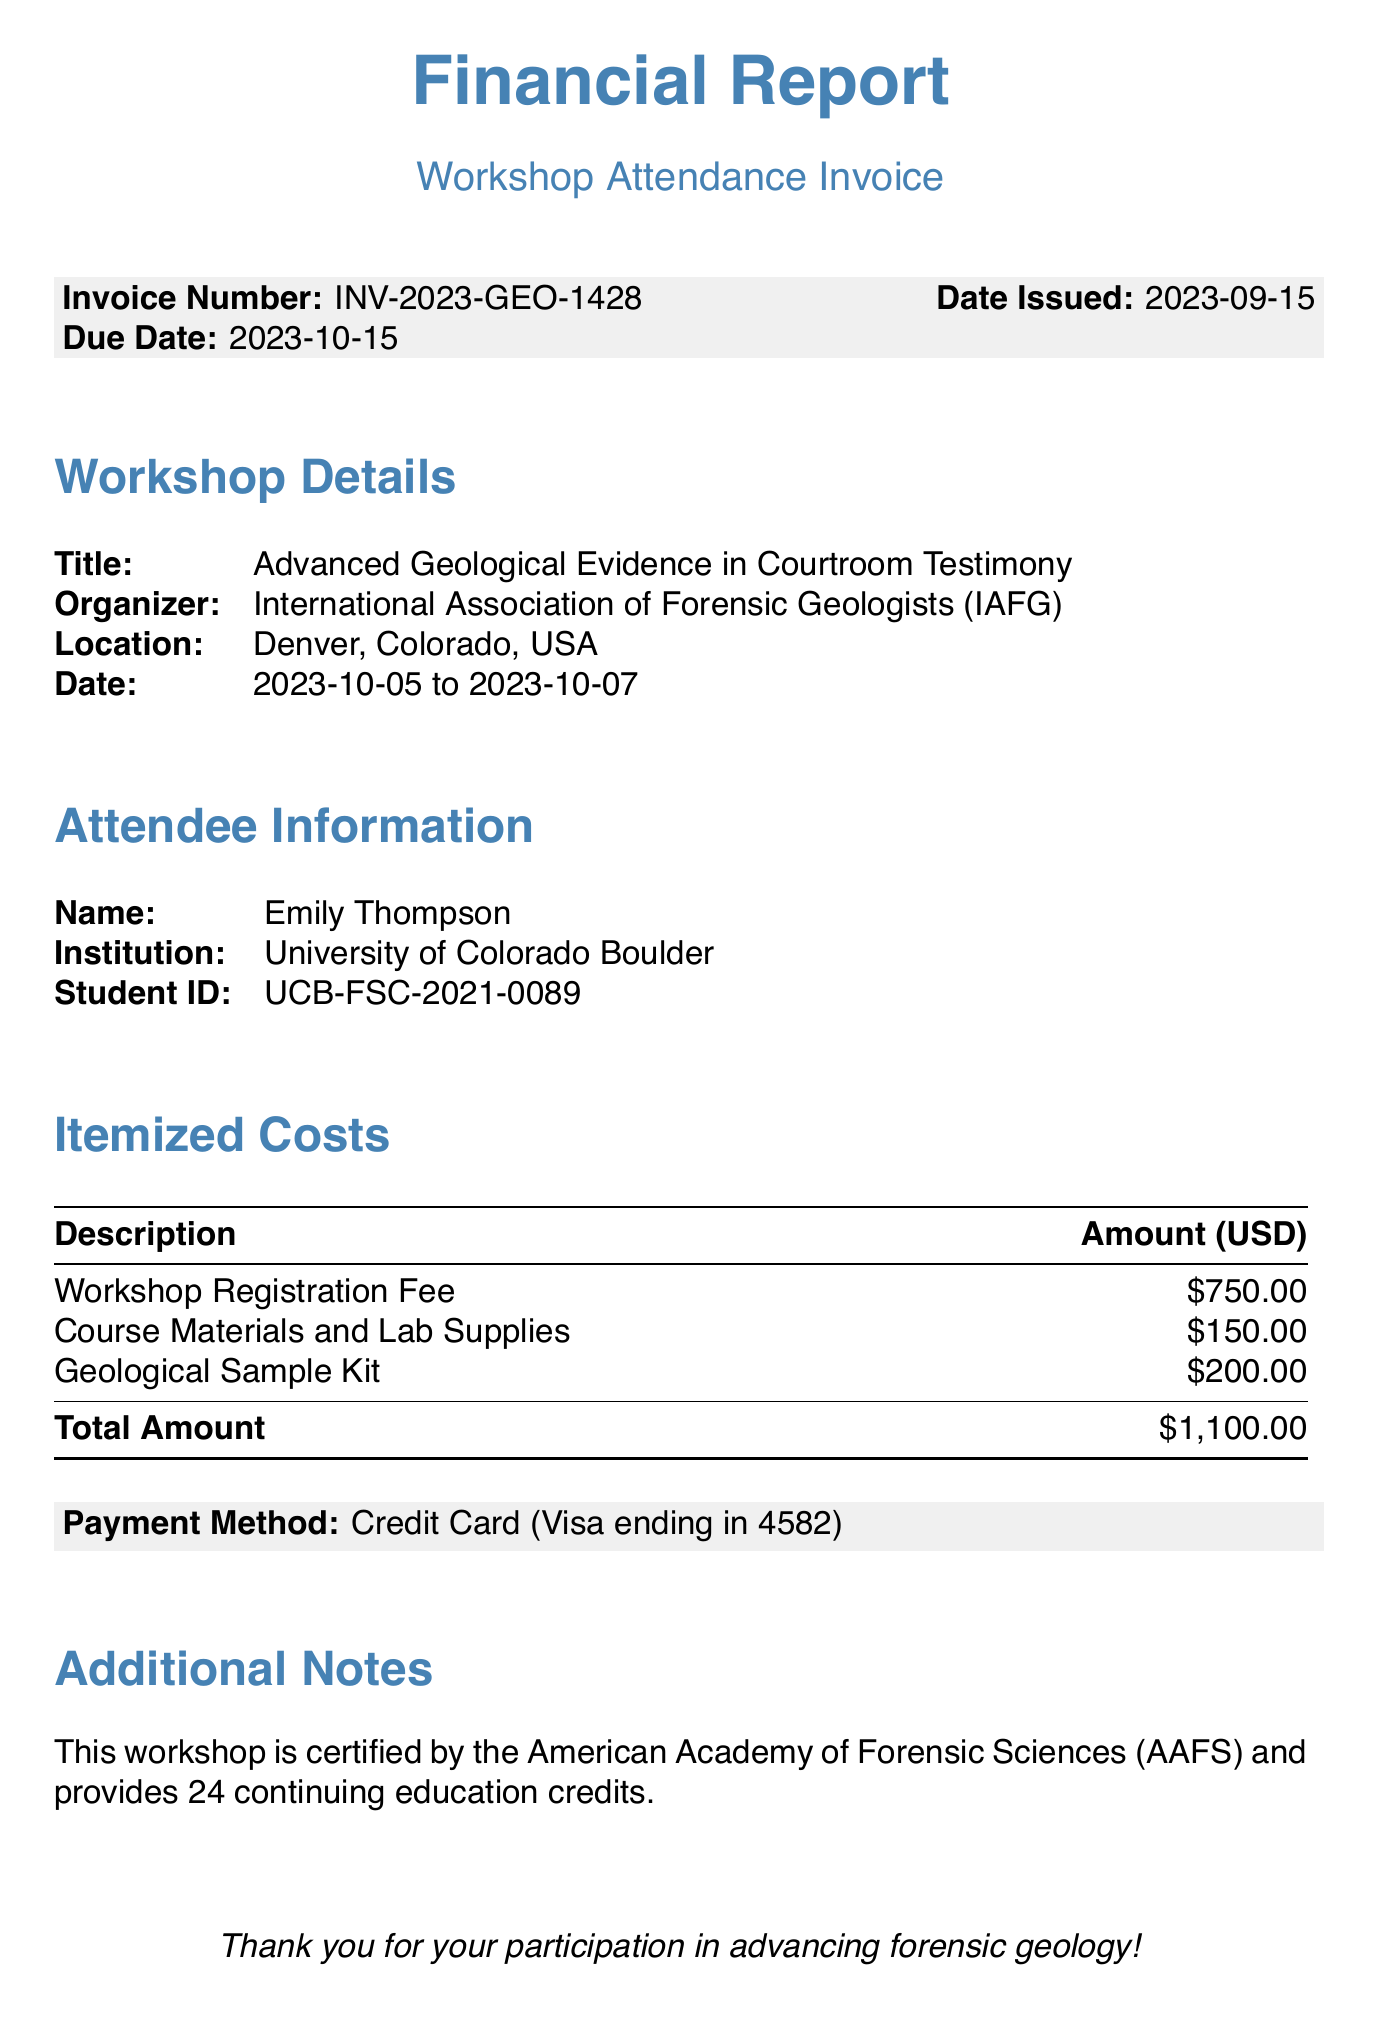What is the invoice number? The invoice number is specified in the document under the relevant section.
Answer: INV-2023-GEO-1428 What is the total amount due? The total amount due is calculated from the itemized costs listed in the document.
Answer: $1,100.00 Who is organizing the workshop? The organizer of the workshop is stated clearly in the workshop details.
Answer: International Association of Forensic Geologists (IAFG) What are the dates of the workshop? The dates of the workshop are provided in the workshop details section.
Answer: 2023-10-05 to 2023-10-07 What is the payment method? The document mentions the payment method used for the invoice.
Answer: Credit Card (Visa ending in 4582) How many continuing education credits does the workshop provide? The number of continuing education credits is mentioned in the additional notes.
Answer: 24 What is the total cost of the Geological Sample Kit? The cost of the Geological Sample Kit is listed in the itemized costs section.
Answer: $200.00 What is the name of the attendee? The name of the attendee is stated in the attendee information section.
Answer: Emily Thompson What is the name of the institution? The name of the institution is specified in the attendee information.
Answer: University of Colorado Boulder 